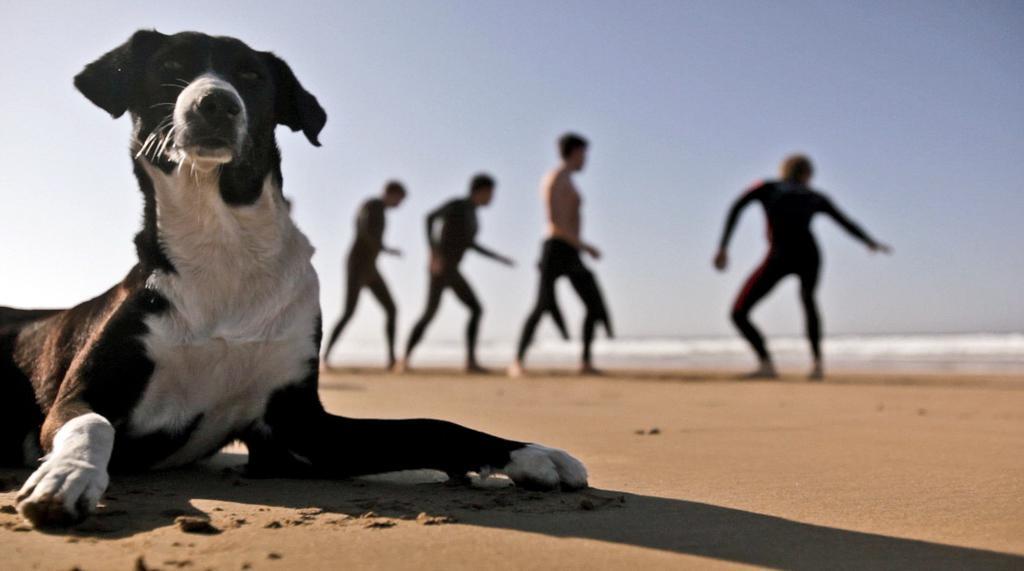In one or two sentences, can you explain what this image depicts? In this image we can see persons standing and we can also see the dog and the sky. 